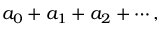Convert formula to latex. <formula><loc_0><loc_0><loc_500><loc_500>a _ { 0 } + a _ { 1 } + a _ { 2 } + \cdots ,</formula> 